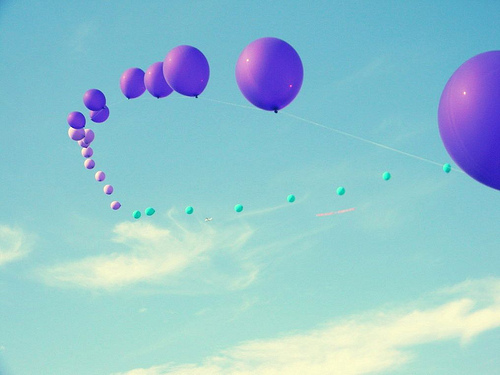<image>
Can you confirm if the baloon is under the sky? Yes. The baloon is positioned underneath the sky, with the sky above it in the vertical space. 